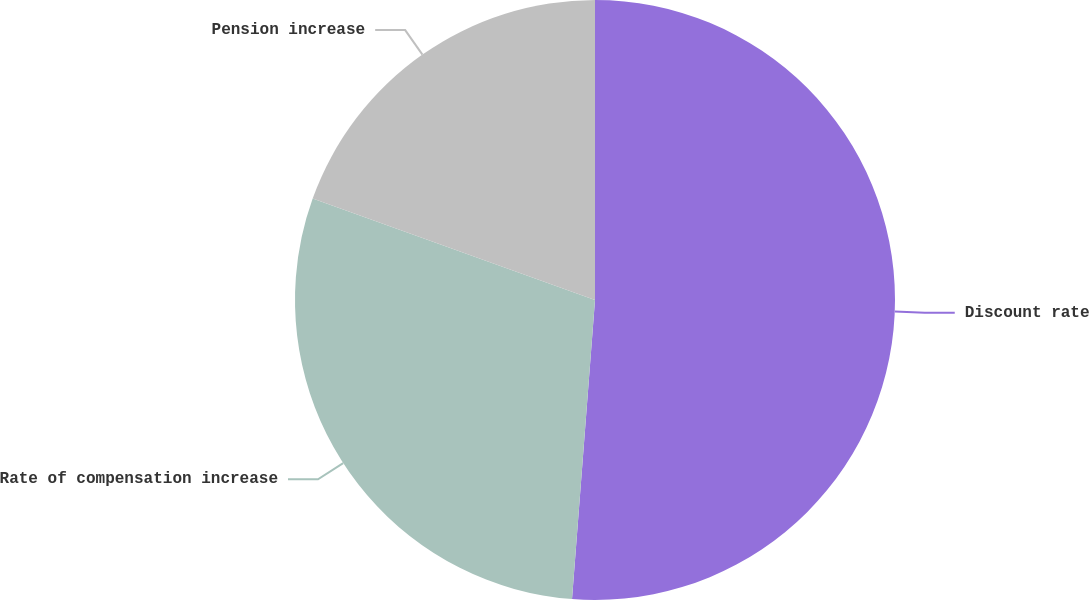Convert chart to OTSL. <chart><loc_0><loc_0><loc_500><loc_500><pie_chart><fcel>Discount rate<fcel>Rate of compensation increase<fcel>Pension increase<nl><fcel>51.22%<fcel>29.27%<fcel>19.51%<nl></chart> 